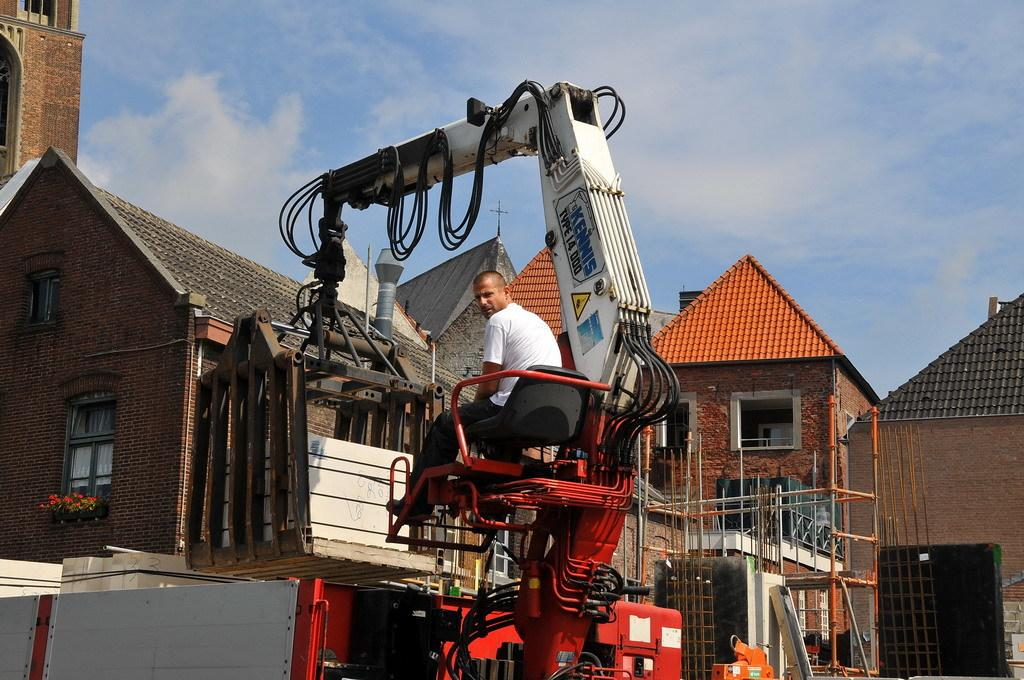What type of machinery is present in the image? There is a crane in the image. What is the person in the image doing? The person is sitting in a chair in the image. What type of structures can be seen in the image? There are buildings visible in the image. What is visible in the background of the image? The sky is visible in the image, and there are clouds in the sky. How many cakes are being served on the mountain in the image? There is no mountain or cakes present in the image. Can you describe the ant's behavior in the image? There is no ant present in the image. 